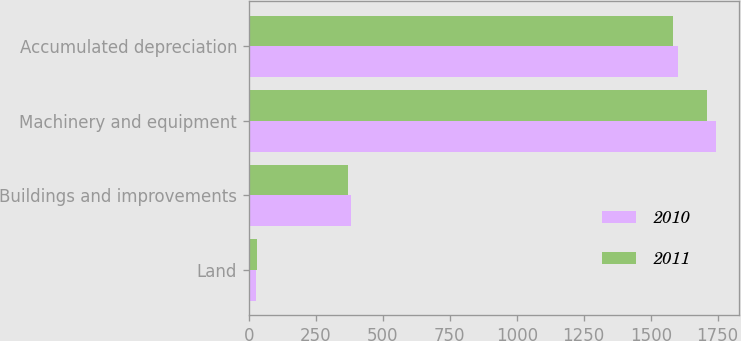Convert chart to OTSL. <chart><loc_0><loc_0><loc_500><loc_500><stacked_bar_chart><ecel><fcel>Land<fcel>Buildings and improvements<fcel>Machinery and equipment<fcel>Accumulated depreciation<nl><fcel>2010<fcel>28.5<fcel>381<fcel>1743.4<fcel>1601.5<nl><fcel>2011<fcel>32.4<fcel>370<fcel>1709.8<fcel>1582.9<nl></chart> 